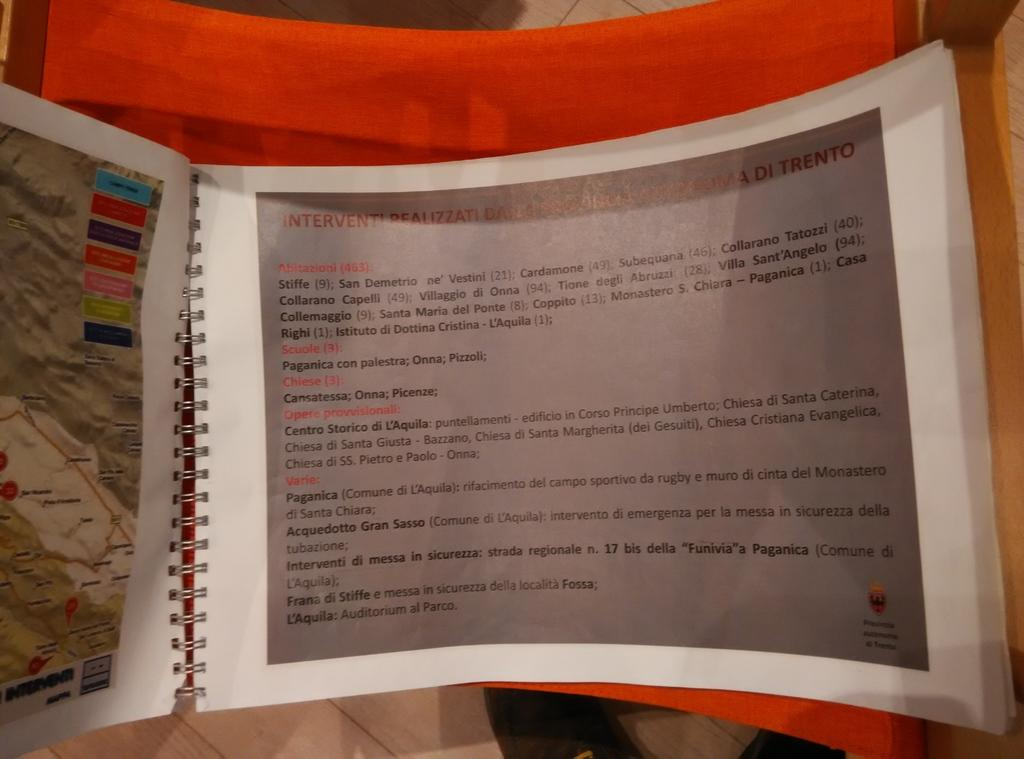<image>
Render a clear and concise summary of the photo. a spiral bound book is opened to a page that says Interventi at the beginnning 